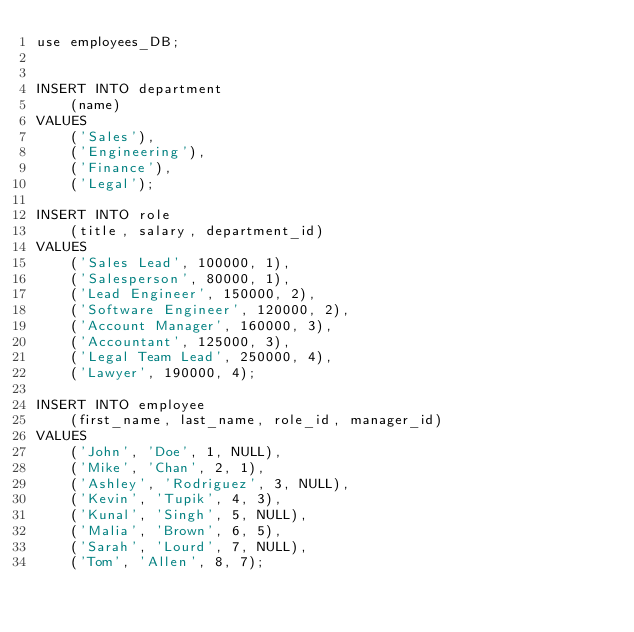<code> <loc_0><loc_0><loc_500><loc_500><_SQL_>use employees_DB;


INSERT INTO department
    (name)
VALUES
    ('Sales'),
    ('Engineering'),
    ('Finance'),
    ('Legal');

INSERT INTO role
    (title, salary, department_id)
VALUES
    ('Sales Lead', 100000, 1),
    ('Salesperson', 80000, 1),
    ('Lead Engineer', 150000, 2),
    ('Software Engineer', 120000, 2),
    ('Account Manager', 160000, 3),
    ('Accountant', 125000, 3),
    ('Legal Team Lead', 250000, 4),
    ('Lawyer', 190000, 4);

INSERT INTO employee
    (first_name, last_name, role_id, manager_id)
VALUES
    ('John', 'Doe', 1, NULL),
    ('Mike', 'Chan', 2, 1),
    ('Ashley', 'Rodriguez', 3, NULL),
    ('Kevin', 'Tupik', 4, 3),
    ('Kunal', 'Singh', 5, NULL),
    ('Malia', 'Brown', 6, 5),
    ('Sarah', 'Lourd', 7, NULL),
    ('Tom', 'Allen', 8, 7);
</code> 